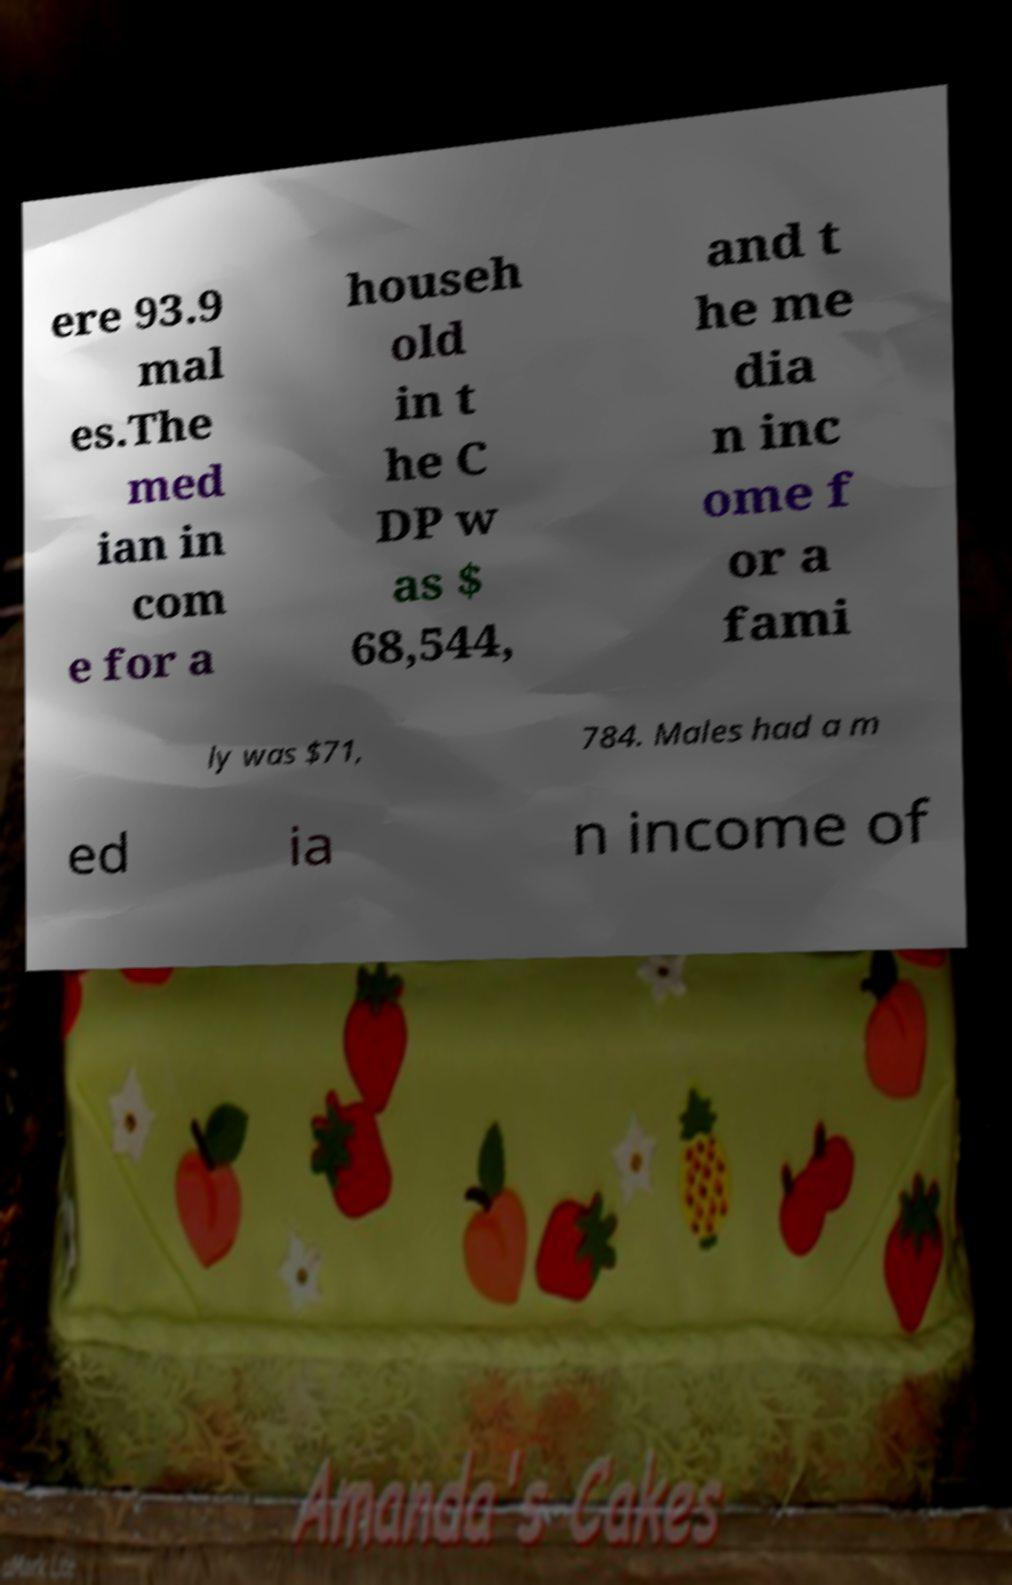Can you accurately transcribe the text from the provided image for me? ere 93.9 mal es.The med ian in com e for a househ old in t he C DP w as $ 68,544, and t he me dia n inc ome f or a fami ly was $71, 784. Males had a m ed ia n income of 